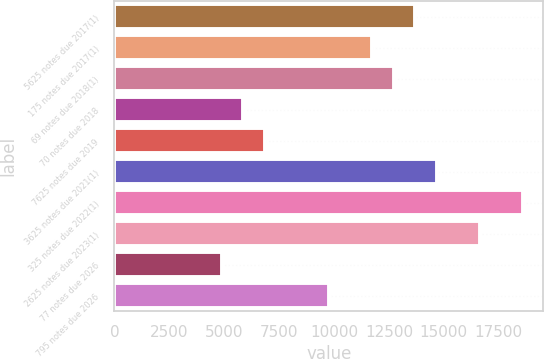Convert chart. <chart><loc_0><loc_0><loc_500><loc_500><bar_chart><fcel>5625 notes due 2017(1)<fcel>175 notes due 2017(1)<fcel>69 notes due 2018(1)<fcel>70 notes due 2018<fcel>7625 notes due 2019<fcel>3625 notes due 2021(1)<fcel>325 notes due 2022(1)<fcel>2625 notes due 2023(1)<fcel>77 notes due 2026<fcel>795 notes due 2026<nl><fcel>13697.2<fcel>11740.6<fcel>12718.9<fcel>5870.8<fcel>6849.1<fcel>14675.5<fcel>18588.7<fcel>16632.1<fcel>4892.5<fcel>9784<nl></chart> 